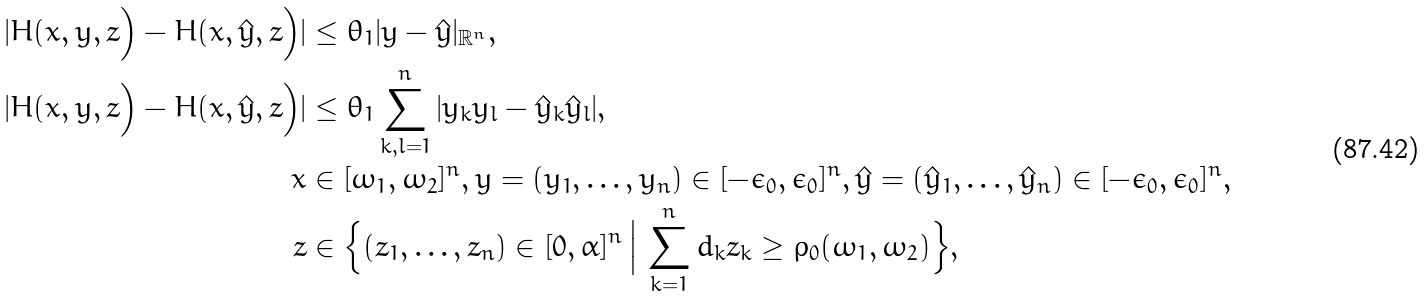Convert formula to latex. <formula><loc_0><loc_0><loc_500><loc_500>| H ( x , y , z \Big ) - H ( x , \hat { y } , z \Big ) | & \leq \theta _ { 1 } | y - \hat { y } | _ { \mathbb { R } ^ { n } } , \\ | H ( x , y , z \Big ) - H ( x , \hat { y } , z \Big ) | & \leq \theta _ { 1 } \sum _ { k , l = 1 } ^ { n } | y _ { k } y _ { l } - \hat { y } _ { k } \hat { y } _ { l } | , \\ x & \in [ \omega _ { 1 } , \omega _ { 2 } ] ^ { n } , y = ( y _ { 1 } , \dots , y _ { n } ) \in [ - \epsilon _ { 0 } , \epsilon _ { 0 } ] ^ { n } , \hat { y } = ( \hat { y } _ { 1 } , \dots , \hat { y } _ { n } ) \in [ - \epsilon _ { 0 } , \epsilon _ { 0 } ] ^ { n } , \\ z & \in \Big \{ ( z _ { 1 } , \dots , z _ { n } ) \in [ 0 , \alpha ] ^ { n } \, \Big | \, \sum _ { k = 1 } ^ { n } d _ { k } z _ { k } \geq \rho _ { 0 } ( \omega _ { 1 } , \omega _ { 2 } ) \Big \} ,</formula> 